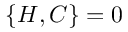<formula> <loc_0><loc_0><loc_500><loc_500>\{ H , C \} = 0</formula> 